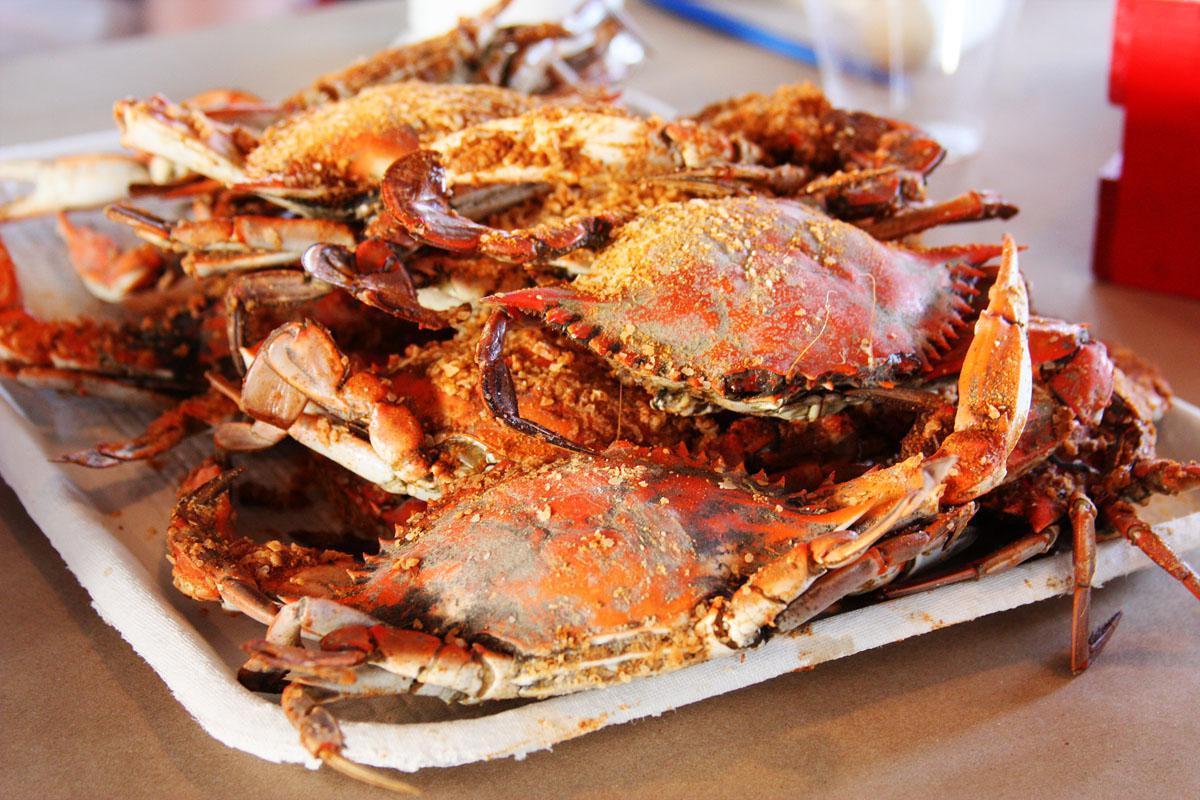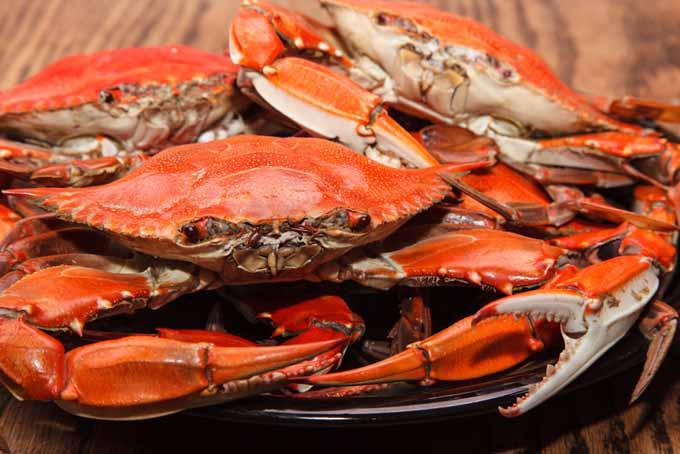The first image is the image on the left, the second image is the image on the right. Analyze the images presented: Is the assertion "The right image features a round plate containing one rightside-up crab with its red-orange shell and claws intact." valid? Answer yes or no. No. The first image is the image on the left, the second image is the image on the right. For the images shown, is this caption "IN at least one image there is a dead and full crab with it head intact sitting on a white plate." true? Answer yes or no. No. 